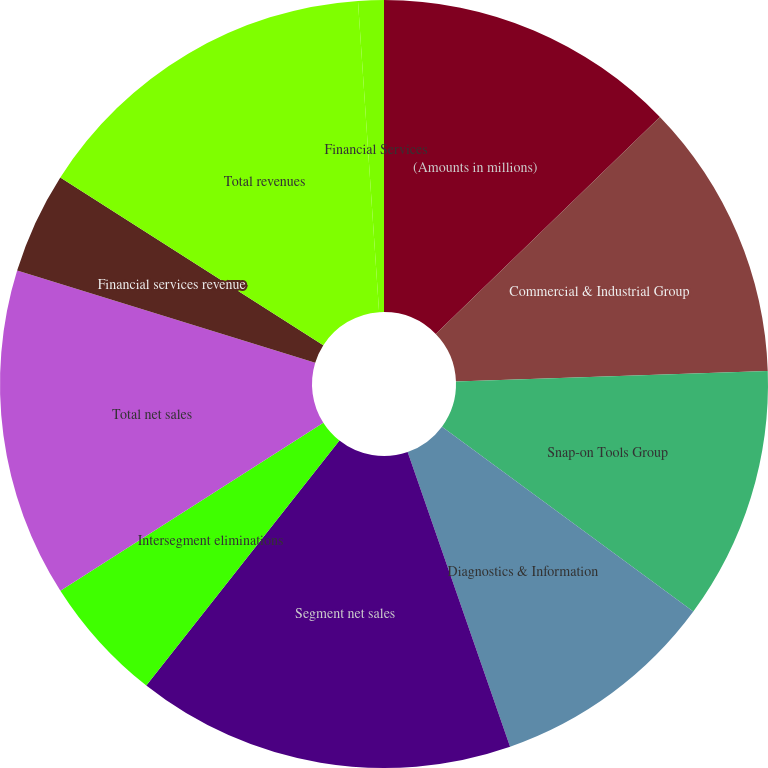Convert chart to OTSL. <chart><loc_0><loc_0><loc_500><loc_500><pie_chart><fcel>(Amounts in millions)<fcel>Commercial & Industrial Group<fcel>Snap-on Tools Group<fcel>Diagnostics & Information<fcel>Segment net sales<fcel>Intersegment eliminations<fcel>Total net sales<fcel>Financial services revenue<fcel>Total revenues<fcel>Financial Services<nl><fcel>12.76%<fcel>11.7%<fcel>10.64%<fcel>9.58%<fcel>15.95%<fcel>5.33%<fcel>13.82%<fcel>4.27%<fcel>14.88%<fcel>1.08%<nl></chart> 